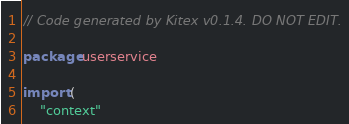Convert code to text. <code><loc_0><loc_0><loc_500><loc_500><_Go_>// Code generated by Kitex v0.1.4. DO NOT EDIT.

package userservice

import (
	"context"</code> 